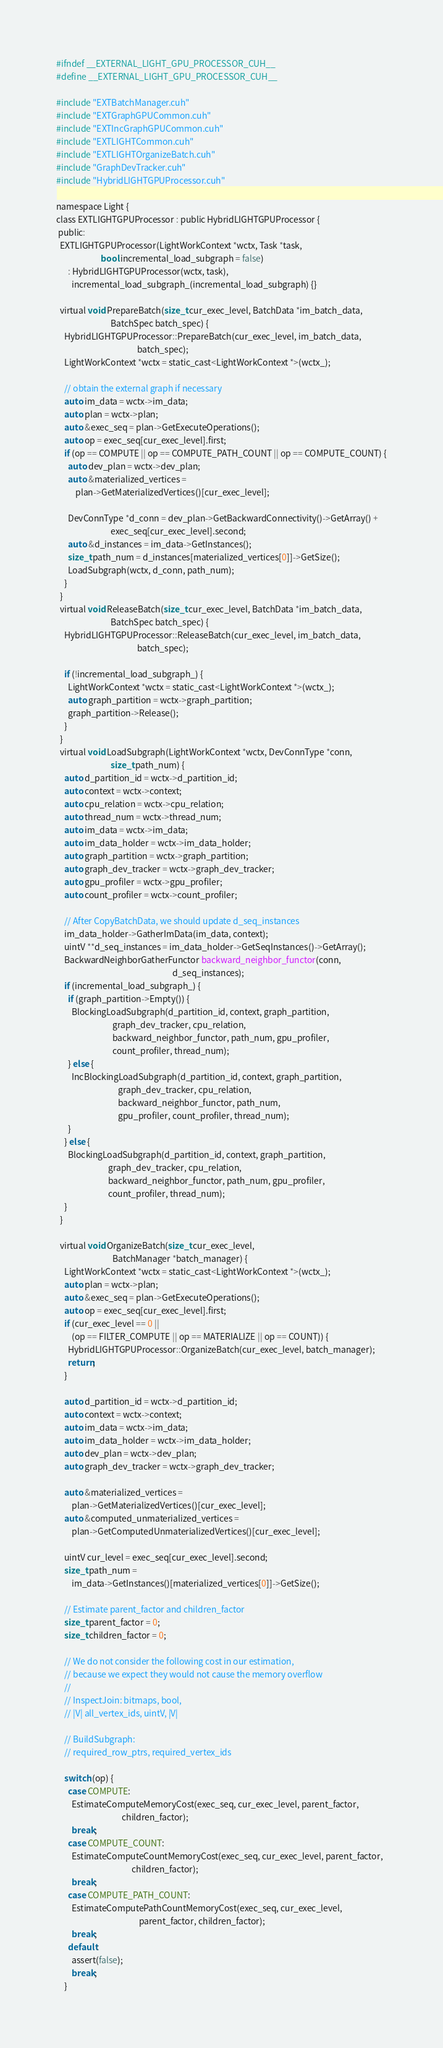<code> <loc_0><loc_0><loc_500><loc_500><_Cuda_>#ifndef __EXTERNAL_LIGHT_GPU_PROCESSOR_CUH__
#define __EXTERNAL_LIGHT_GPU_PROCESSOR_CUH__

#include "EXTBatchManager.cuh"
#include "EXTGraphGPUCommon.cuh"
#include "EXTIncGraphGPUCommon.cuh"
#include "EXTLIGHTCommon.cuh"
#include "EXTLIGHTOrganizeBatch.cuh"
#include "GraphDevTracker.cuh"
#include "HybridLIGHTGPUProcessor.cuh"

namespace Light {
class EXTLIGHTGPUProcessor : public HybridLIGHTGPUProcessor {
 public:
  EXTLIGHTGPUProcessor(LightWorkContext *wctx, Task *task,
                       bool incremental_load_subgraph = false)
      : HybridLIGHTGPUProcessor(wctx, task),
        incremental_load_subgraph_(incremental_load_subgraph) {}

  virtual void PrepareBatch(size_t cur_exec_level, BatchData *im_batch_data,
                            BatchSpec batch_spec) {
    HybridLIGHTGPUProcessor::PrepareBatch(cur_exec_level, im_batch_data,
                                          batch_spec);
    LightWorkContext *wctx = static_cast<LightWorkContext *>(wctx_);

    // obtain the external graph if necessary
    auto im_data = wctx->im_data;
    auto plan = wctx->plan;
    auto &exec_seq = plan->GetExecuteOperations();
    auto op = exec_seq[cur_exec_level].first;
    if (op == COMPUTE || op == COMPUTE_PATH_COUNT || op == COMPUTE_COUNT) {
      auto dev_plan = wctx->dev_plan;
      auto &materialized_vertices =
          plan->GetMaterializedVertices()[cur_exec_level];

      DevConnType *d_conn = dev_plan->GetBackwardConnectivity()->GetArray() +
                            exec_seq[cur_exec_level].second;
      auto &d_instances = im_data->GetInstances();
      size_t path_num = d_instances[materialized_vertices[0]]->GetSize();
      LoadSubgraph(wctx, d_conn, path_num);
    }
  }
  virtual void ReleaseBatch(size_t cur_exec_level, BatchData *im_batch_data,
                            BatchSpec batch_spec) {
    HybridLIGHTGPUProcessor::ReleaseBatch(cur_exec_level, im_batch_data,
                                          batch_spec);

    if (!incremental_load_subgraph_) {
      LightWorkContext *wctx = static_cast<LightWorkContext *>(wctx_);
      auto graph_partition = wctx->graph_partition;
      graph_partition->Release();
    }
  }
  virtual void LoadSubgraph(LightWorkContext *wctx, DevConnType *conn,
                            size_t path_num) {
    auto d_partition_id = wctx->d_partition_id;
    auto context = wctx->context;
    auto cpu_relation = wctx->cpu_relation;
    auto thread_num = wctx->thread_num;
    auto im_data = wctx->im_data;
    auto im_data_holder = wctx->im_data_holder;
    auto graph_partition = wctx->graph_partition;
    auto graph_dev_tracker = wctx->graph_dev_tracker;
    auto gpu_profiler = wctx->gpu_profiler;
    auto count_profiler = wctx->count_profiler;

    // After CopyBatchData, we should update d_seq_instances
    im_data_holder->GatherImData(im_data, context);
    uintV **d_seq_instances = im_data_holder->GetSeqInstances()->GetArray();
    BackwardNeighborGatherFunctor backward_neighbor_functor(conn,
                                                            d_seq_instances);
    if (incremental_load_subgraph_) {
      if (graph_partition->Empty()) {
        BlockingLoadSubgraph(d_partition_id, context, graph_partition,
                             graph_dev_tracker, cpu_relation,
                             backward_neighbor_functor, path_num, gpu_profiler,
                             count_profiler, thread_num);
      } else {
        IncBlockingLoadSubgraph(d_partition_id, context, graph_partition,
                                graph_dev_tracker, cpu_relation,
                                backward_neighbor_functor, path_num,
                                gpu_profiler, count_profiler, thread_num);
      }
    } else {
      BlockingLoadSubgraph(d_partition_id, context, graph_partition,
                           graph_dev_tracker, cpu_relation,
                           backward_neighbor_functor, path_num, gpu_profiler,
                           count_profiler, thread_num);
    }
  }

  virtual void OrganizeBatch(size_t cur_exec_level,
                             BatchManager *batch_manager) {
    LightWorkContext *wctx = static_cast<LightWorkContext *>(wctx_);
    auto plan = wctx->plan;
    auto &exec_seq = plan->GetExecuteOperations();
    auto op = exec_seq[cur_exec_level].first;
    if (cur_exec_level == 0 ||
        (op == FILTER_COMPUTE || op == MATERIALIZE || op == COUNT)) {
      HybridLIGHTGPUProcessor::OrganizeBatch(cur_exec_level, batch_manager);
      return;
    }

    auto d_partition_id = wctx->d_partition_id;
    auto context = wctx->context;
    auto im_data = wctx->im_data;
    auto im_data_holder = wctx->im_data_holder;
    auto dev_plan = wctx->dev_plan;
    auto graph_dev_tracker = wctx->graph_dev_tracker;

    auto &materialized_vertices =
        plan->GetMaterializedVertices()[cur_exec_level];
    auto &computed_unmaterialized_vertices =
        plan->GetComputedUnmaterializedVertices()[cur_exec_level];

    uintV cur_level = exec_seq[cur_exec_level].second;
    size_t path_num =
        im_data->GetInstances()[materialized_vertices[0]]->GetSize();

    // Estimate parent_factor and children_factor
    size_t parent_factor = 0;
    size_t children_factor = 0;

    // We do not consider the following cost in our estimation,
    // because we expect they would not cause the memory overflow
    //
    // InspectJoin: bitmaps, bool,
    // |V| all_vertex_ids, uintV, |V|

    // BuildSubgraph:
    // required_row_ptrs, required_vertex_ids

    switch (op) {
      case COMPUTE:
        EstimateComputeMemoryCost(exec_seq, cur_exec_level, parent_factor,
                                  children_factor);
        break;
      case COMPUTE_COUNT:
        EstimateComputeCountMemoryCost(exec_seq, cur_exec_level, parent_factor,
                                       children_factor);
        break;
      case COMPUTE_PATH_COUNT:
        EstimateComputePathCountMemoryCost(exec_seq, cur_exec_level,
                                           parent_factor, children_factor);
        break;
      default:
        assert(false);
        break;
    }
</code> 